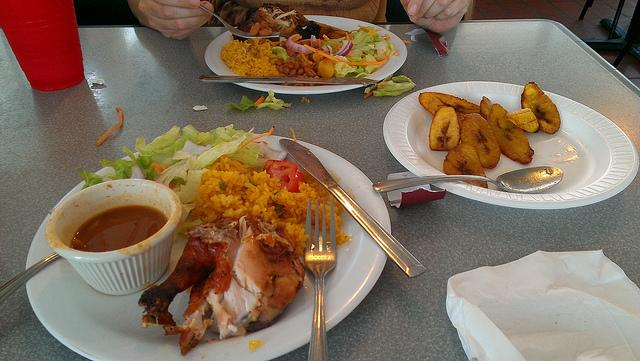What type of rice is on the dishes?

Choices:
A) wild rice
B) spanish rice
C) brown rice
D) white rice spanish rice 